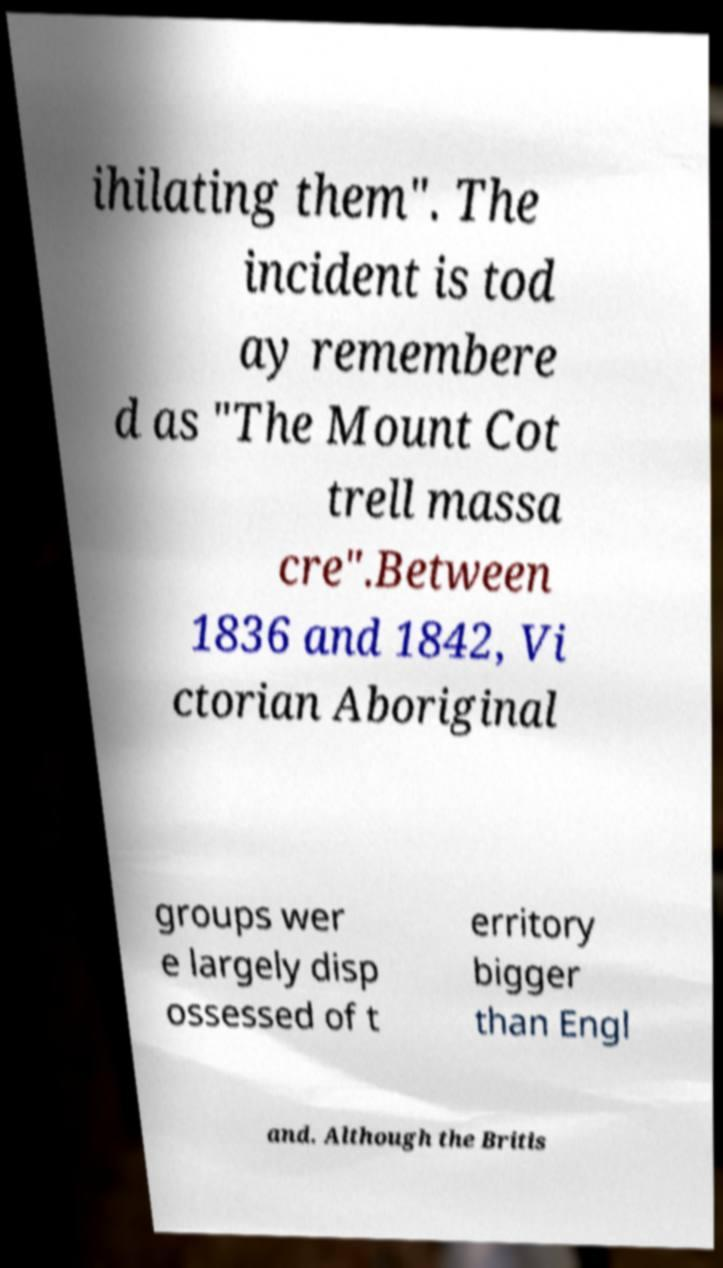Please identify and transcribe the text found in this image. ihilating them". The incident is tod ay remembere d as "The Mount Cot trell massa cre".Between 1836 and 1842, Vi ctorian Aboriginal groups wer e largely disp ossessed of t erritory bigger than Engl and. Although the Britis 